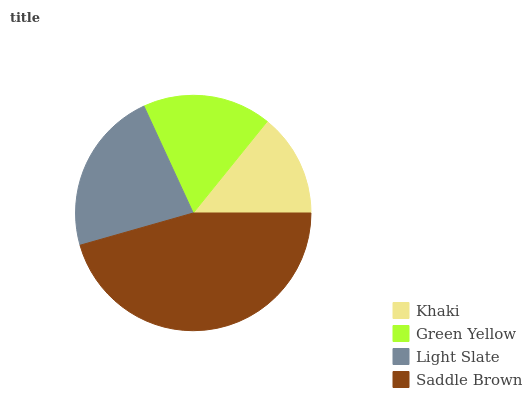Is Khaki the minimum?
Answer yes or no. Yes. Is Saddle Brown the maximum?
Answer yes or no. Yes. Is Green Yellow the minimum?
Answer yes or no. No. Is Green Yellow the maximum?
Answer yes or no. No. Is Green Yellow greater than Khaki?
Answer yes or no. Yes. Is Khaki less than Green Yellow?
Answer yes or no. Yes. Is Khaki greater than Green Yellow?
Answer yes or no. No. Is Green Yellow less than Khaki?
Answer yes or no. No. Is Light Slate the high median?
Answer yes or no. Yes. Is Green Yellow the low median?
Answer yes or no. Yes. Is Saddle Brown the high median?
Answer yes or no. No. Is Khaki the low median?
Answer yes or no. No. 